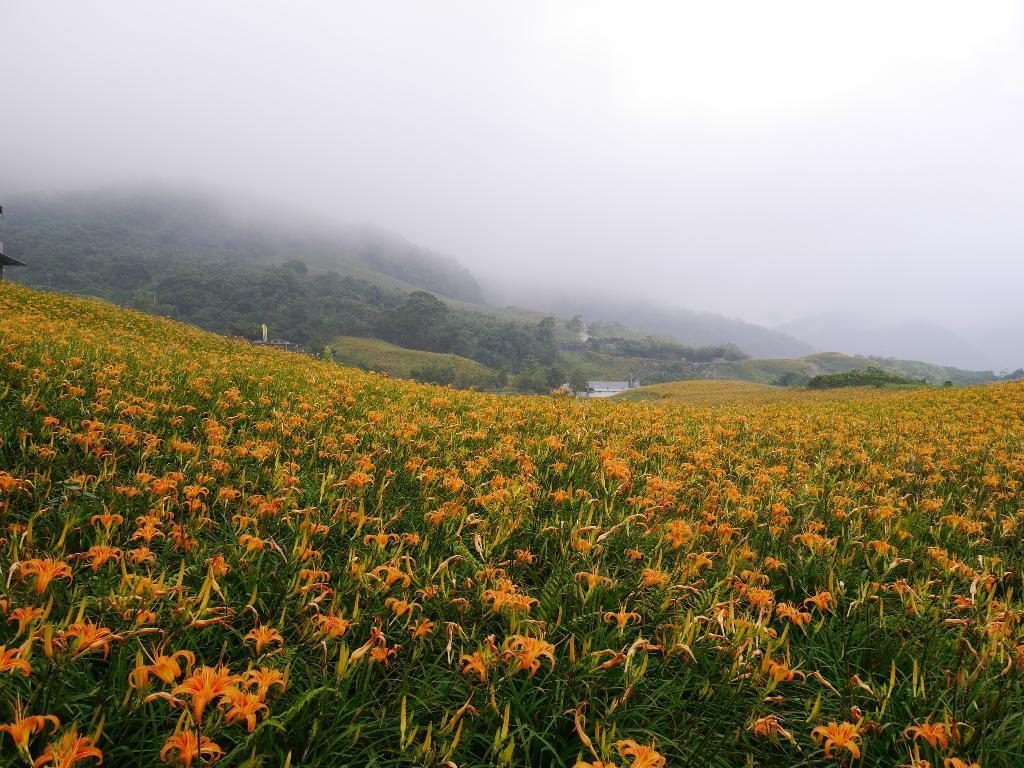Please provide a concise description of this image. In this image we can see there are flower plants, trees and sky. 